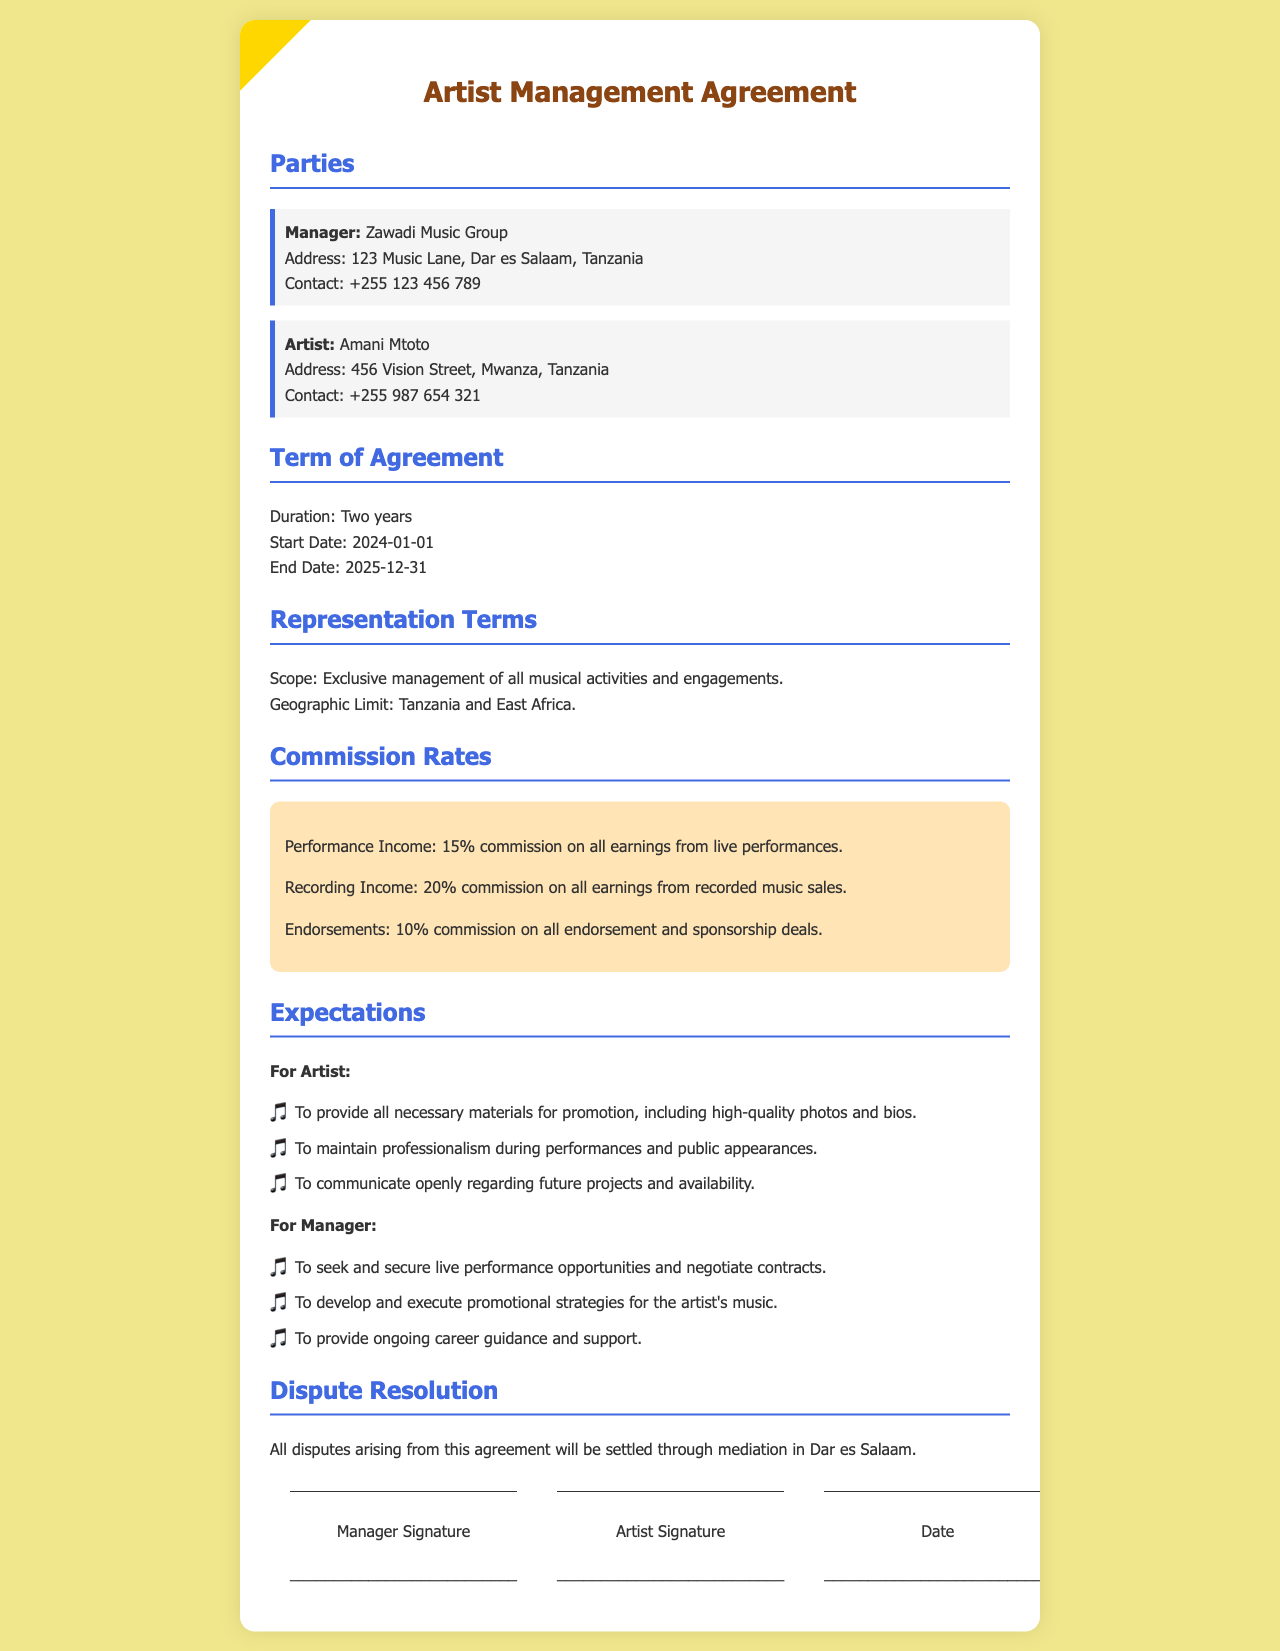what is the name of the manager? The manager's name is listed under the parties section of the document.
Answer: Zawadi Music Group who is the artist? The artist's name is specified in the parties section as well.
Answer: Amani Mtoto what is the commission rate for performance income? The commission rates are detailed in a specific section of the document.
Answer: 15% what is the duration of the agreement? The duration is explicitly mentioned in the term of agreement section.
Answer: Two years what geographic limit is specified in the representation terms? The geographic limit is outlined in the representation terms section of the document.
Answer: Tanzania and East Africa what are the artist's expectations regarding professionalism? The expectations for the artist's professionalism are listed under the expectations section.
Answer: To maintain professionalism during performances and public appearances how much commission is taken from recorded music sales? The document specifies the commission rates for recording income.
Answer: 20% where will disputes be settled? The dispute resolution section indicates where disputes will be addressed.
Answer: Dar es Salaam what is the start date of the agreement? The start date is detailed in the term of agreement section.
Answer: 2024-01-01 